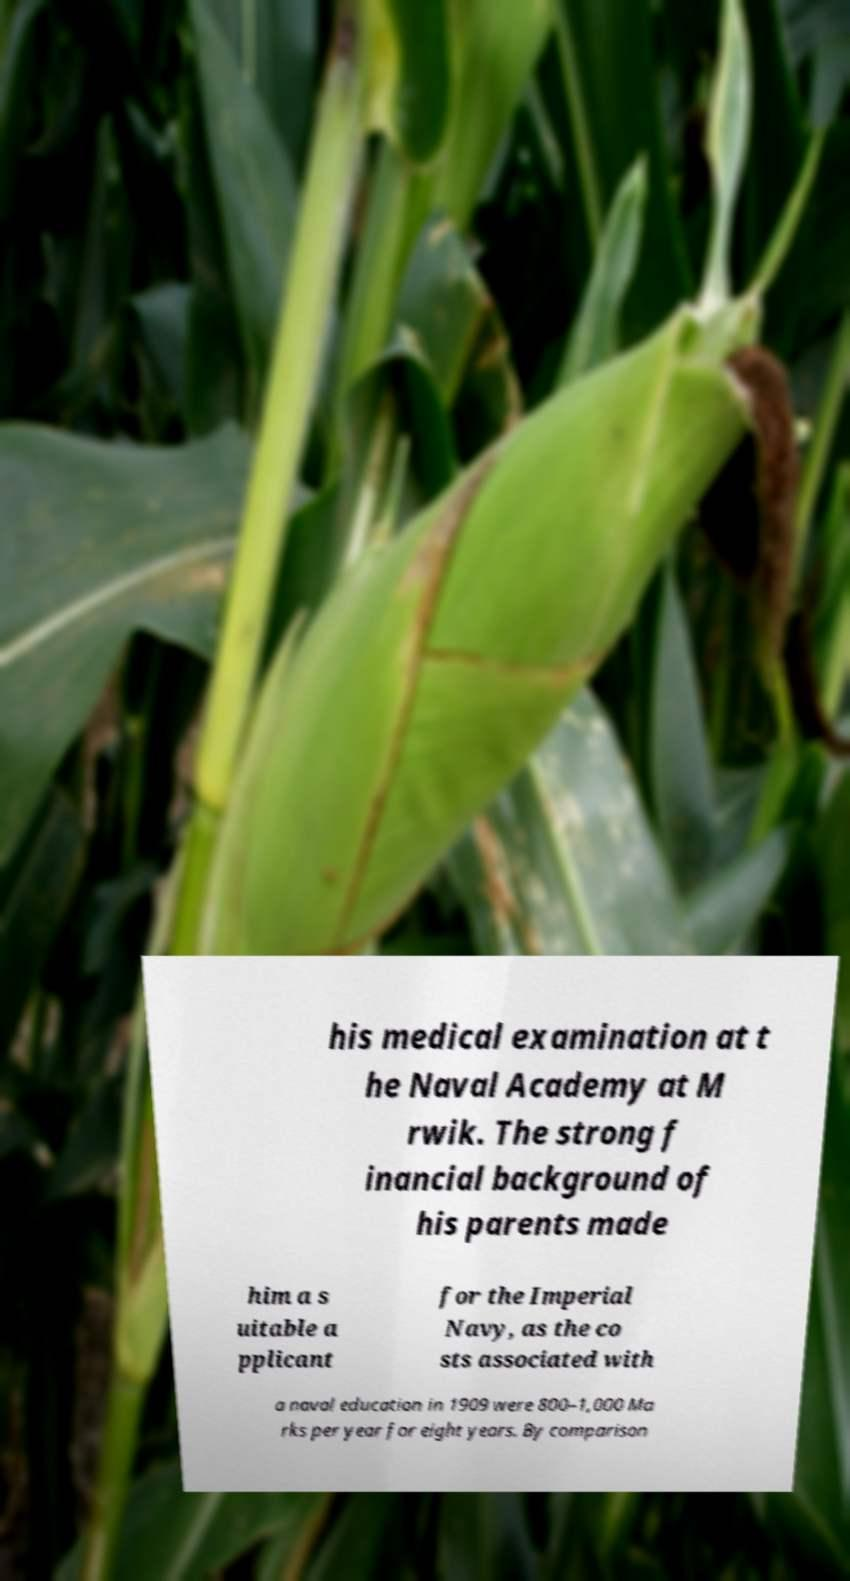Please read and relay the text visible in this image. What does it say? his medical examination at t he Naval Academy at M rwik. The strong f inancial background of his parents made him a s uitable a pplicant for the Imperial Navy, as the co sts associated with a naval education in 1909 were 800–1,000 Ma rks per year for eight years. By comparison 